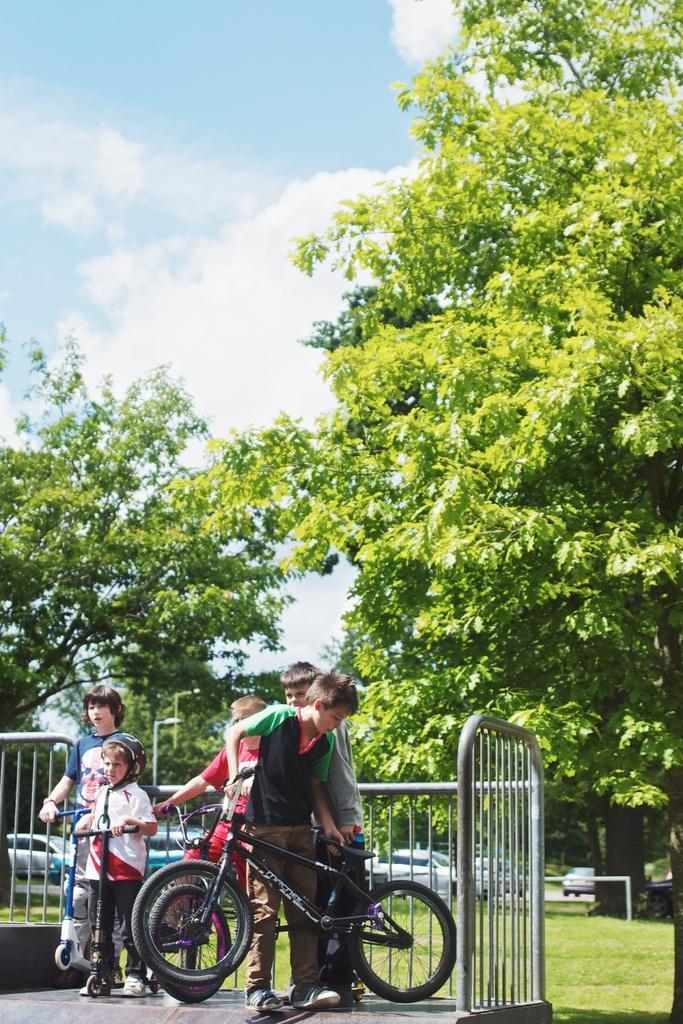What is the main subject of the image? The main subject of the image is boys. What are the boys doing in the image? The boys are with bicycles in the image. What can be seen in the background of the image? There are trees in the background of the image. How would you describe the sky in the image? The sky is filled with clouds in the image. Is there a hose being used by the boys to water the trees in the image? There is no hose present in the image, and the boys are not using one to water the trees. 